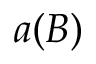<formula> <loc_0><loc_0><loc_500><loc_500>a ( B )</formula> 